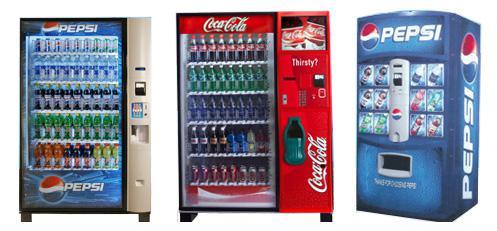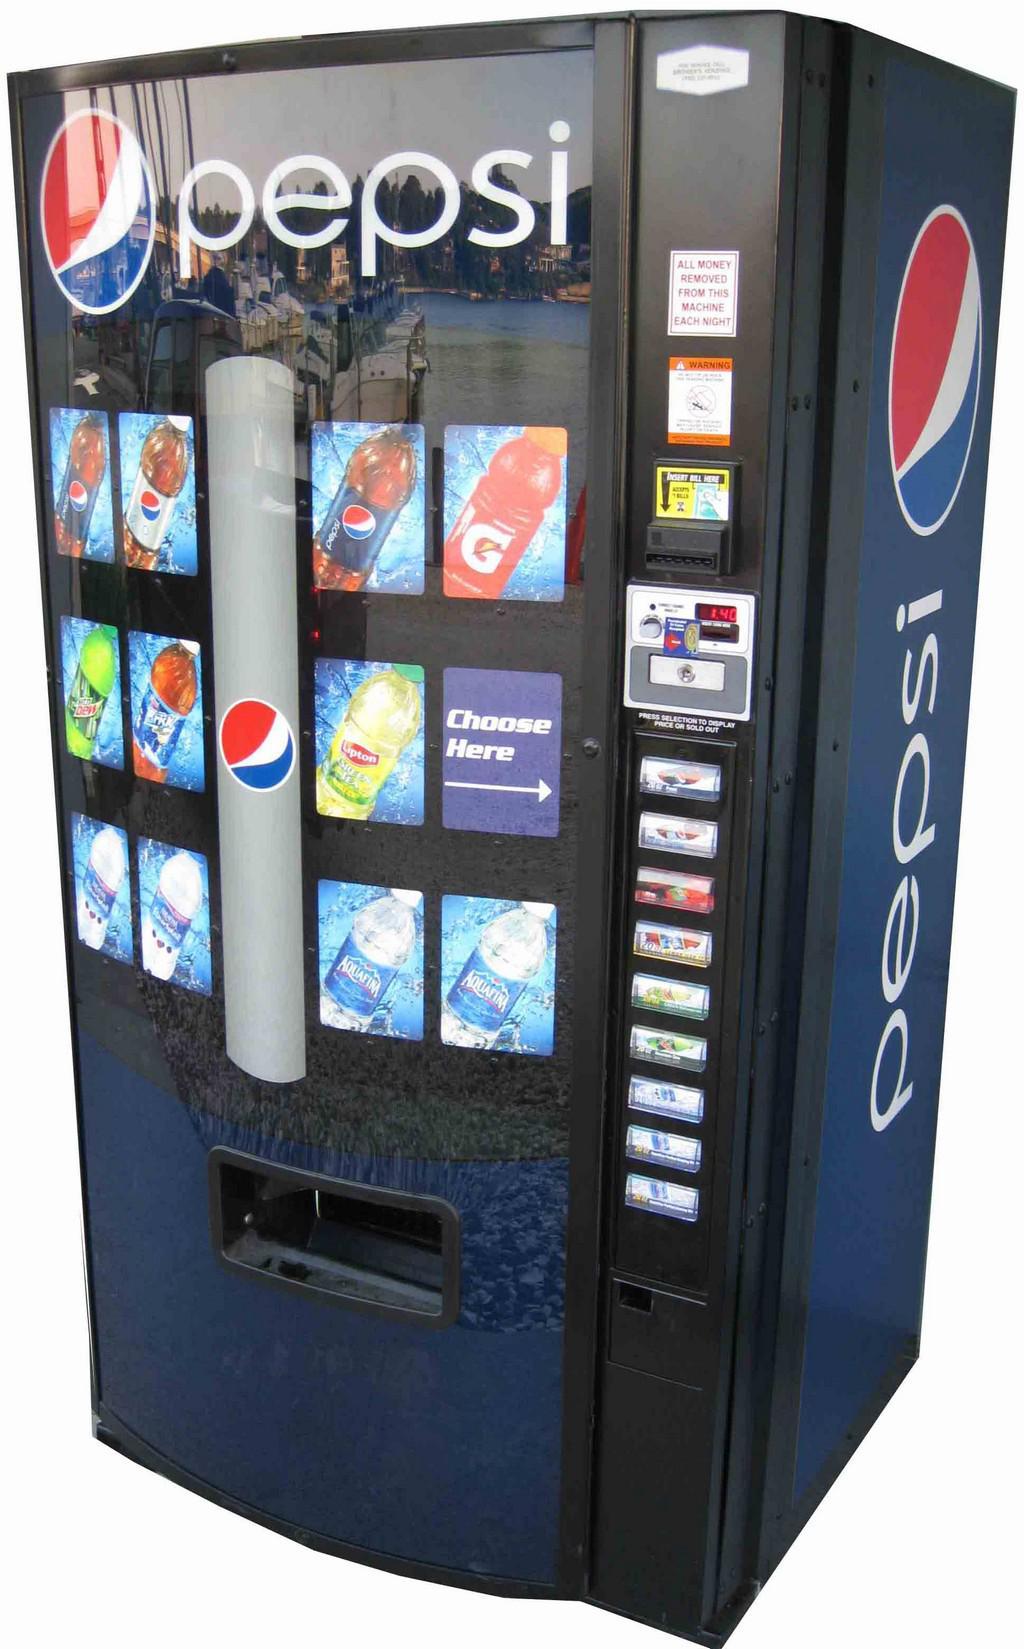The first image is the image on the left, the second image is the image on the right. Given the left and right images, does the statement "Each image shows predominantly one vending machine, and all vending machines shown are blue." hold true? Answer yes or no. No. The first image is the image on the left, the second image is the image on the right. Examine the images to the left and right. Is the description "In one of the images, a pepsi machine stands alone." accurate? Answer yes or no. Yes. 